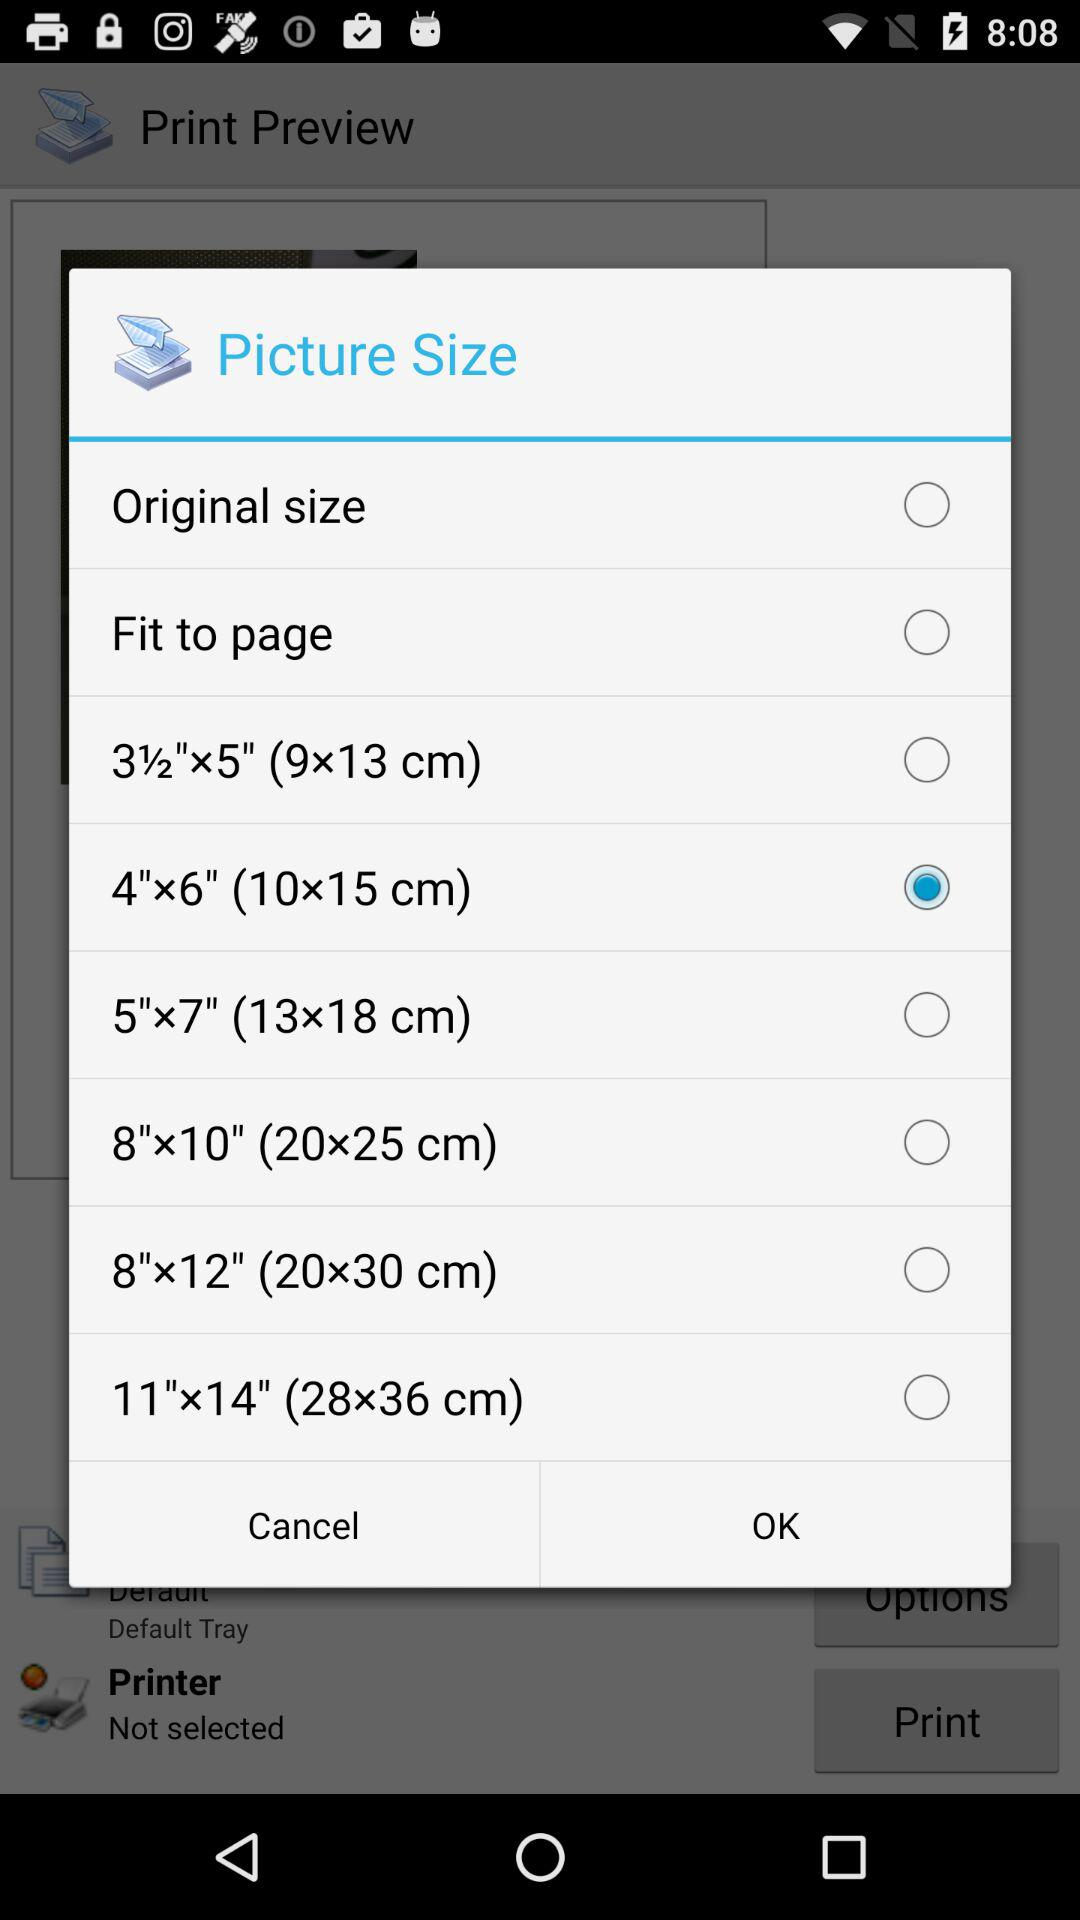What are the picture size options that I can select? The options are "Original size", "Fit to page", "3½"x5" (9x13 cm)", "4"x6" (10x15 cm)", "5"x7" (13x18 cm)", "8"x10" (20x25 cm)", "8"x12" (20x30 cm)" and "11"x14" (28x36 cm)". 